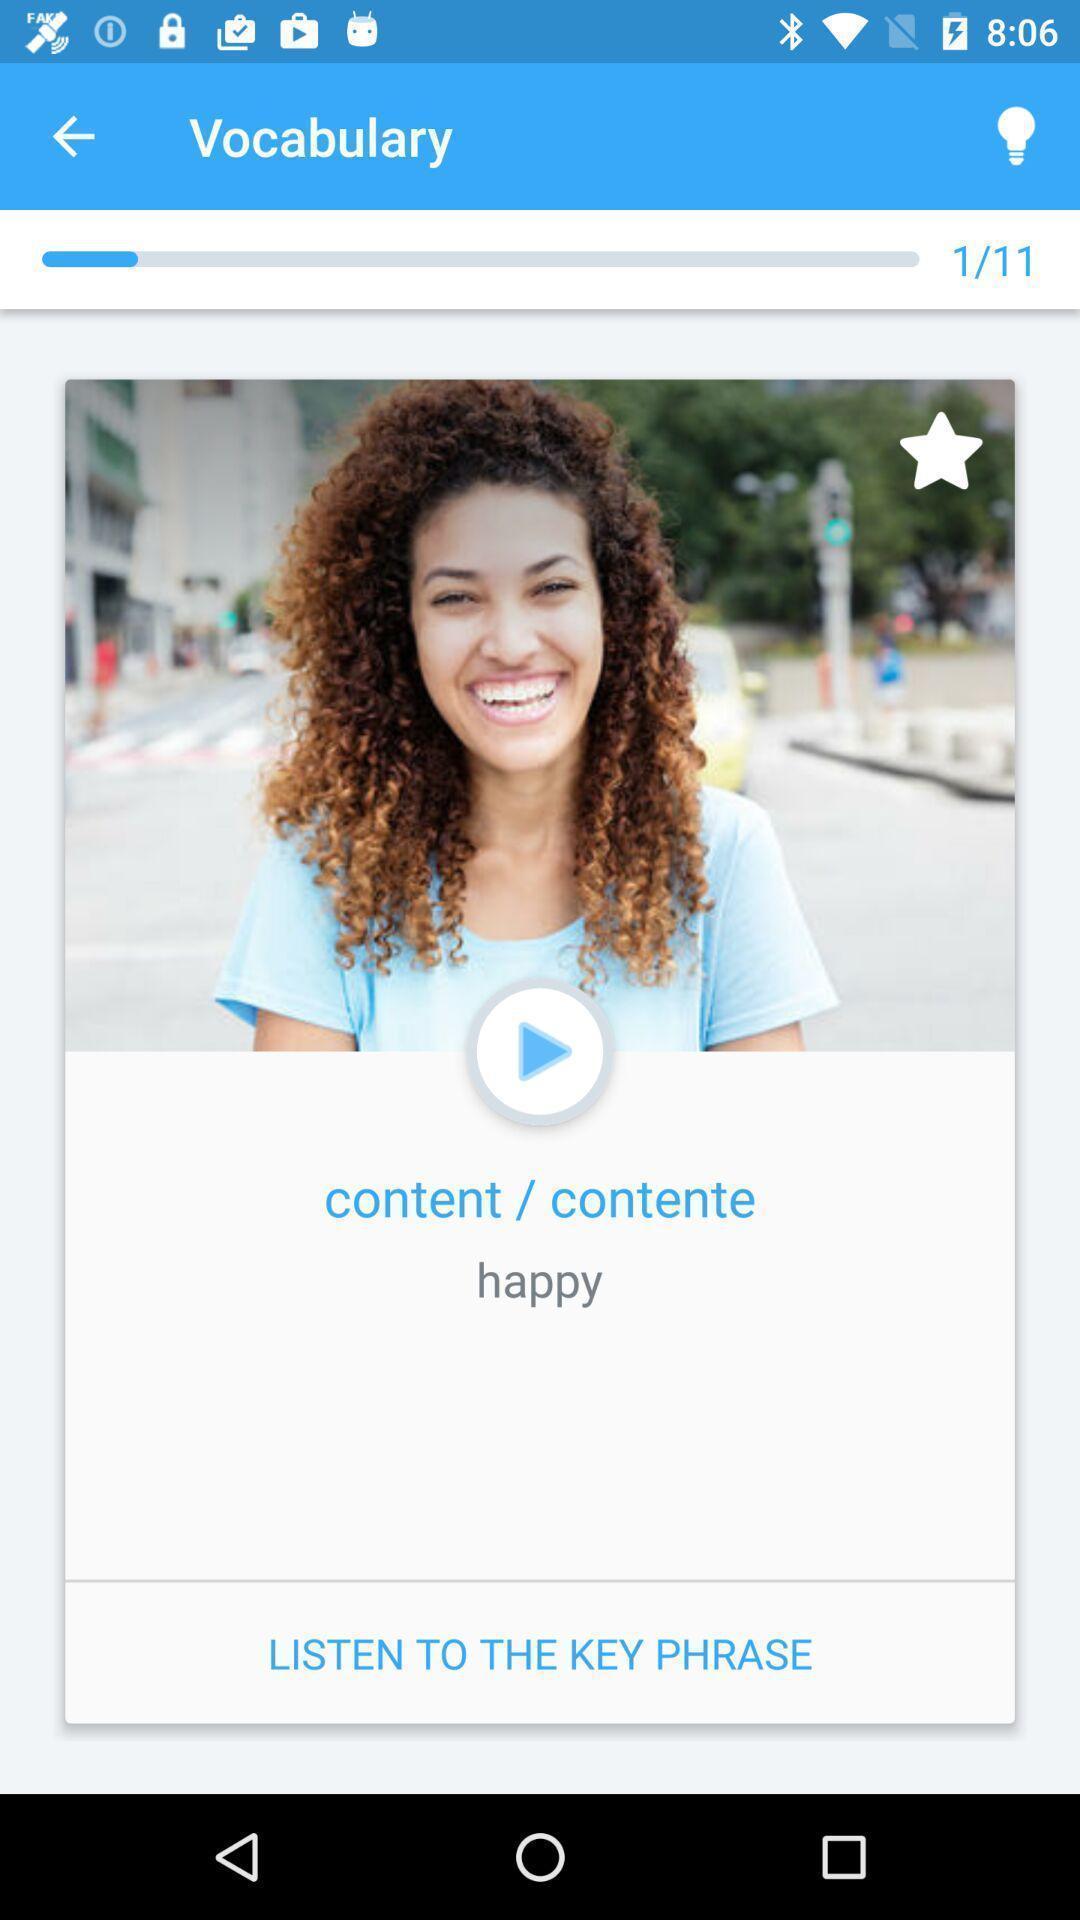Describe the visual elements of this screenshot. Pop-up showing reminder to listen to key phrase. 